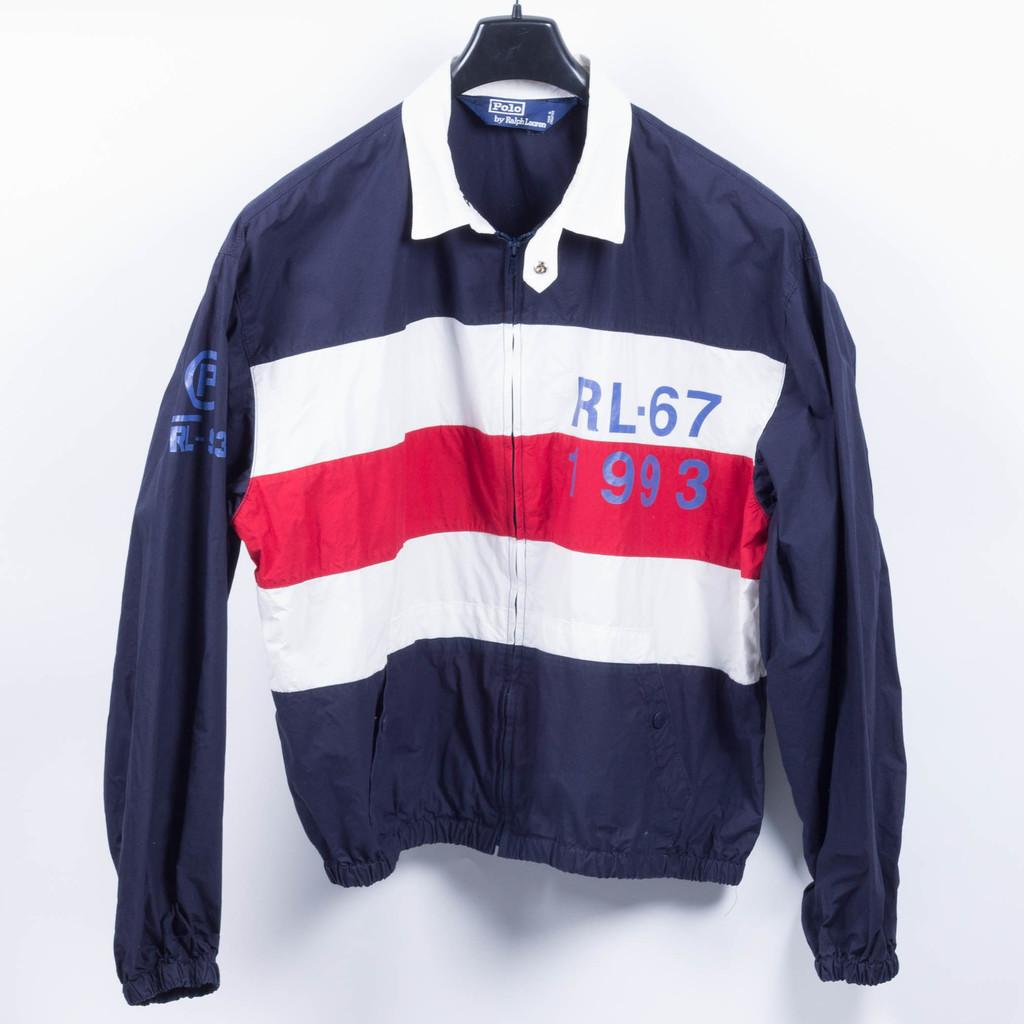<image>
Write a terse but informative summary of the picture. a blue, red and white sweater wit hthe text rl67 on the left hand side of the chest. 